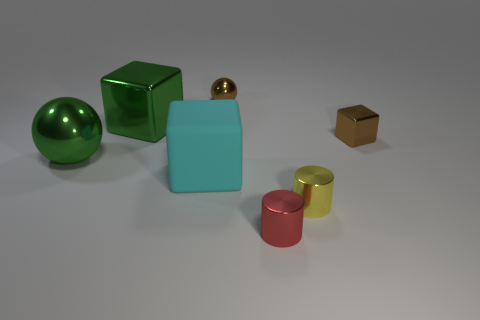Subtract all big cubes. How many cubes are left? 1 Subtract all cyan cubes. How many cubes are left? 2 Add 1 tiny metal balls. How many objects exist? 8 Subtract 0 red cubes. How many objects are left? 7 Subtract all blocks. How many objects are left? 4 Subtract 1 cylinders. How many cylinders are left? 1 Subtract all blue balls. Subtract all green cylinders. How many balls are left? 2 Subtract all yellow balls. How many cyan cubes are left? 1 Subtract all rubber balls. Subtract all large green metal objects. How many objects are left? 5 Add 6 tiny brown metal objects. How many tiny brown metal objects are left? 8 